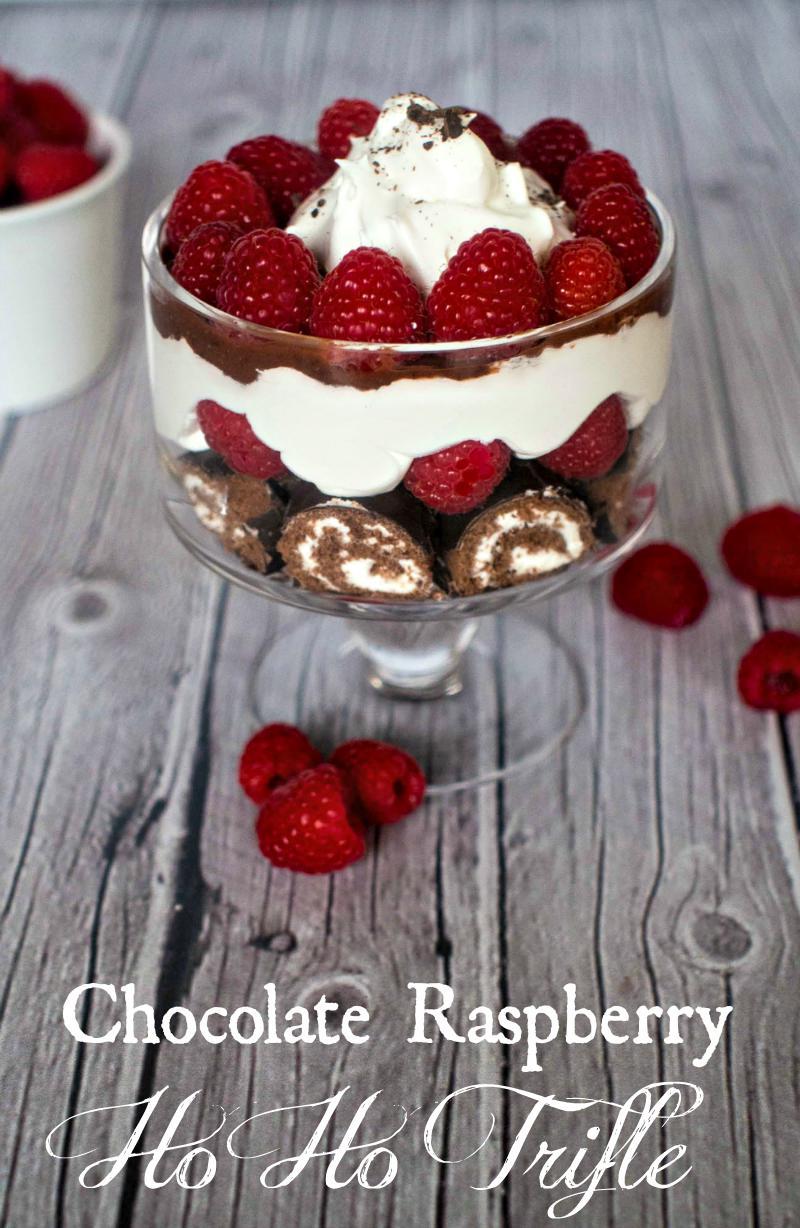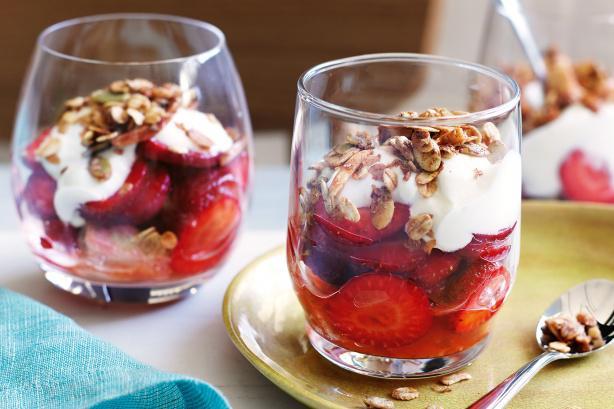The first image is the image on the left, the second image is the image on the right. For the images shown, is this caption "A dessert in a footed glass has a neat row of berries around the rim for garnish." true? Answer yes or no. Yes. 